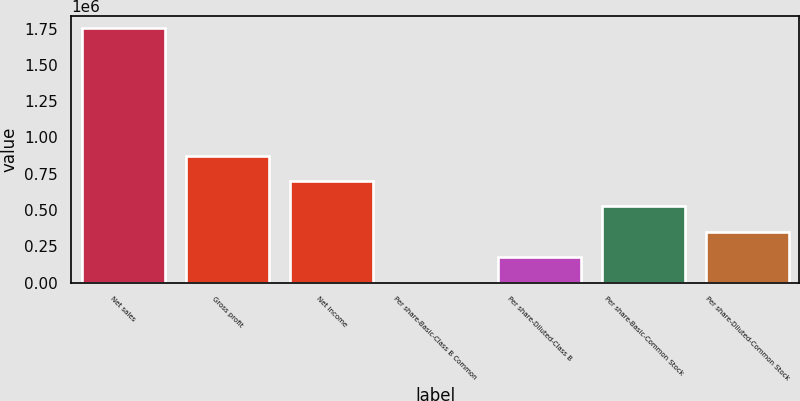Convert chart to OTSL. <chart><loc_0><loc_0><loc_500><loc_500><bar_chart><fcel>Net sales<fcel>Gross profit<fcel>Net income<fcel>Per share-Basic-Class B Common<fcel>Per share-Diluted-Class B<fcel>Per share-Basic-Common Stock<fcel>Per share-Diluted-Common Stock<nl><fcel>1.75104e+06<fcel>875518<fcel>700414<fcel>0.62<fcel>175104<fcel>525311<fcel>350208<nl></chart> 